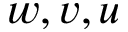Convert formula to latex. <formula><loc_0><loc_0><loc_500><loc_500>w , v , u</formula> 